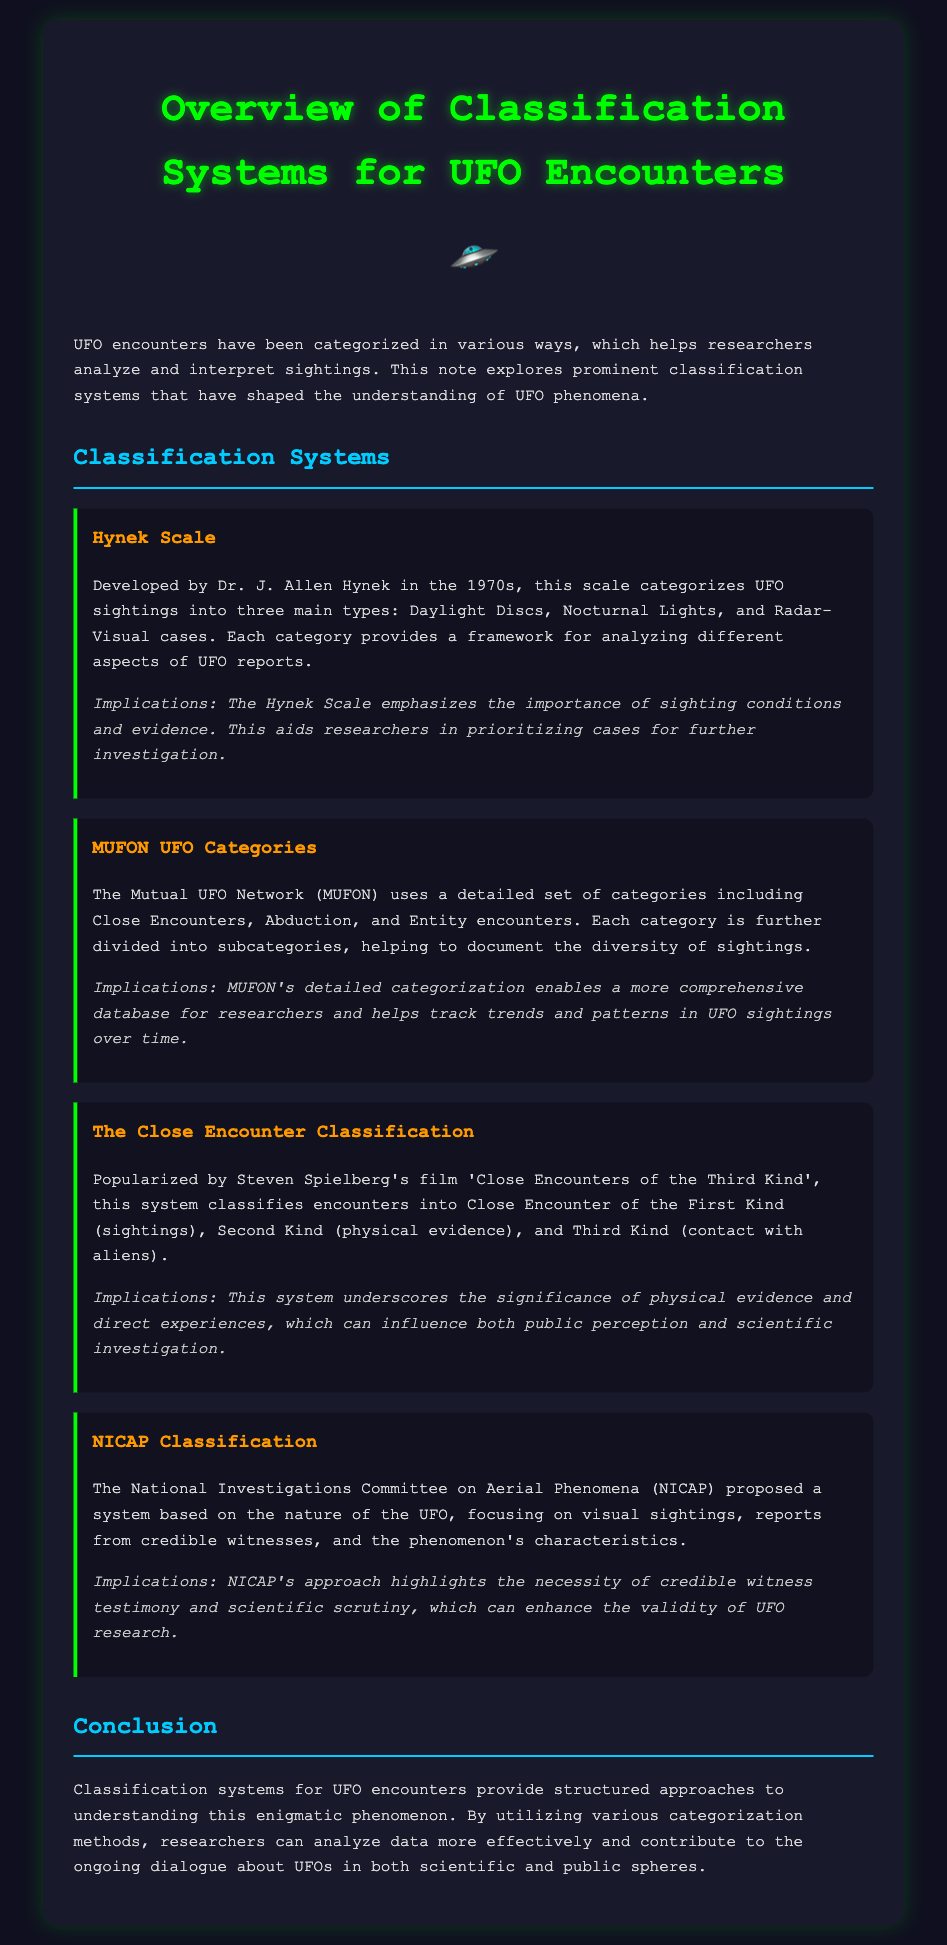What is the Hynek Scale? The Hynek Scale is a classification system developed by Dr. J. Allen Hynek, categorizing UFO sightings into three main types.
Answer: a classification system What does MUFON commonly categorize? MUFON commonly categorizes UFOs as Close Encounters, Abduction, and Entity encounters.
Answer: Close Encounters, Abduction, and Entity encounters What are the three Close Encounter types? The three Close Encounter types are First Kind (sightings), Second Kind (physical evidence), and Third Kind (contact with aliens).
Answer: First Kind, Second Kind, Third Kind What is the NICAP's focus in classification? NICAP's focus is on the nature of the UFO, credible witness reports, and the phenomenon's characteristics.
Answer: the nature of the UFO Why is the Hynek Scale significant for research? The Hynek Scale emphasizes the importance of sighting conditions and evidence for prioritizing cases.
Answer: prioritizing cases How many main types does the Hynek Scale include? The Hynek Scale includes three main types of UFO sightings.
Answer: three What did the NICAP emphasize for UFO research? NICAP emphasized the necessity of credible witness testimony and scientific scrutiny.
Answer: credible witness testimony What did the Close Encounter classification popularize? The Close Encounter classification was popularized by Steven Spielberg's film 'Close Encounters of the Third Kind'.
Answer: Steven Spielberg's film What does MUFON's detailed categorization help track? MUFON's detailed categorization helps track trends and patterns in UFO sightings over time.
Answer: trends and patterns 